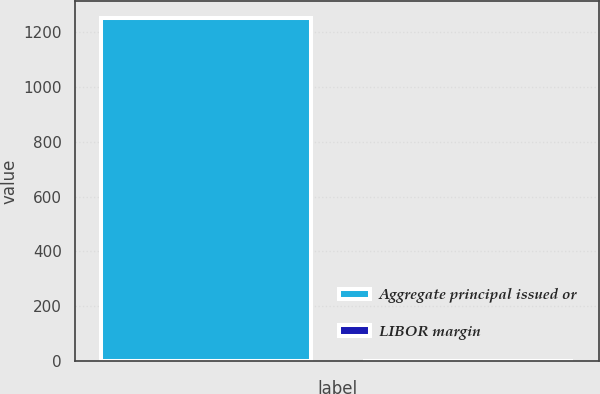Convert chart. <chart><loc_0><loc_0><loc_500><loc_500><bar_chart><fcel>Aggregate principal issued or<fcel>LIBOR margin<nl><fcel>1250<fcel>2<nl></chart> 